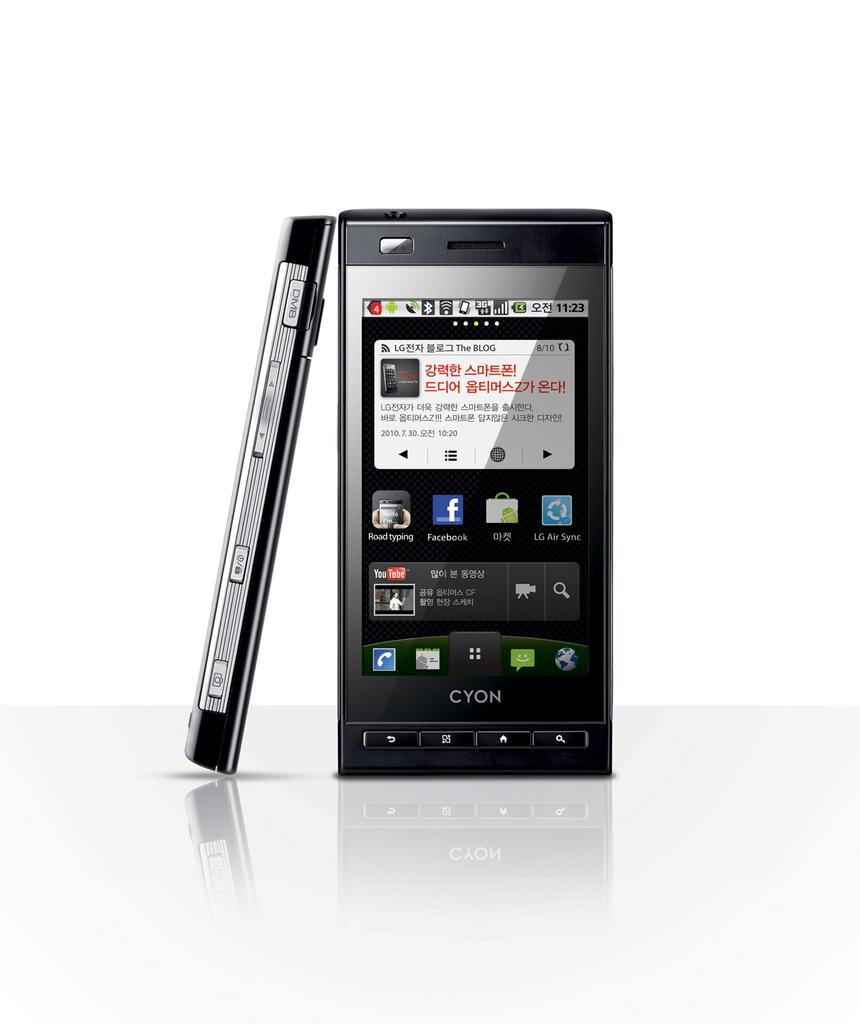<image>
Write a terse but informative summary of the picture. Two Cyon phones one is lending against the other with a white backgroud 